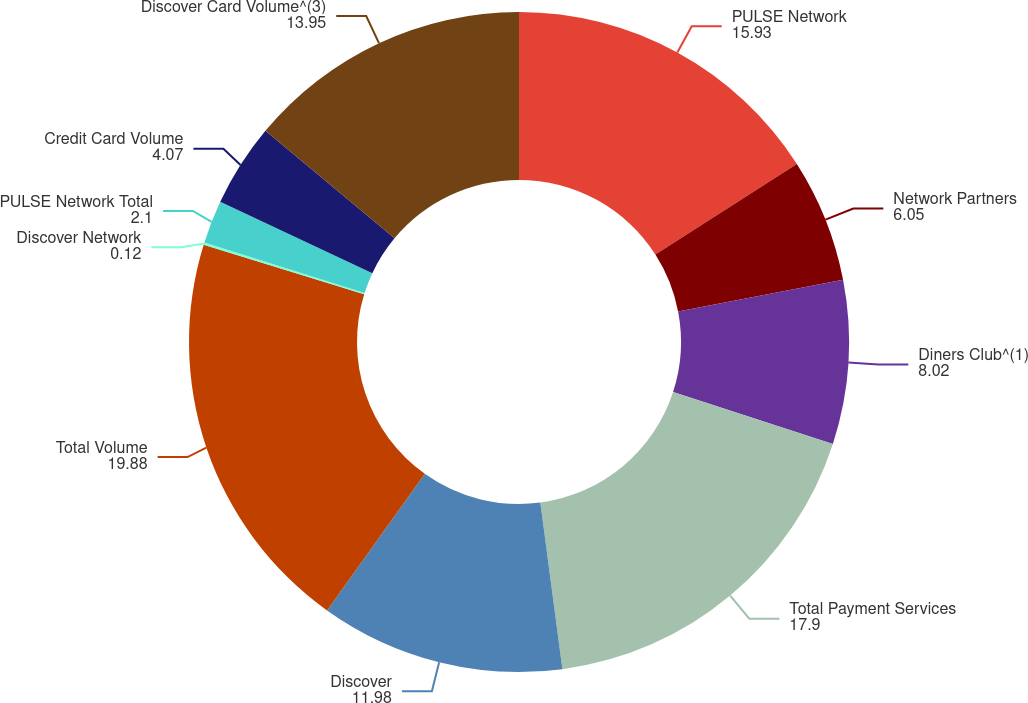Convert chart to OTSL. <chart><loc_0><loc_0><loc_500><loc_500><pie_chart><fcel>PULSE Network<fcel>Network Partners<fcel>Diners Club^(1)<fcel>Total Payment Services<fcel>Discover<fcel>Total Volume<fcel>Discover Network<fcel>PULSE Network Total<fcel>Credit Card Volume<fcel>Discover Card Volume^(3)<nl><fcel>15.93%<fcel>6.05%<fcel>8.02%<fcel>17.9%<fcel>11.98%<fcel>19.88%<fcel>0.12%<fcel>2.1%<fcel>4.07%<fcel>13.95%<nl></chart> 